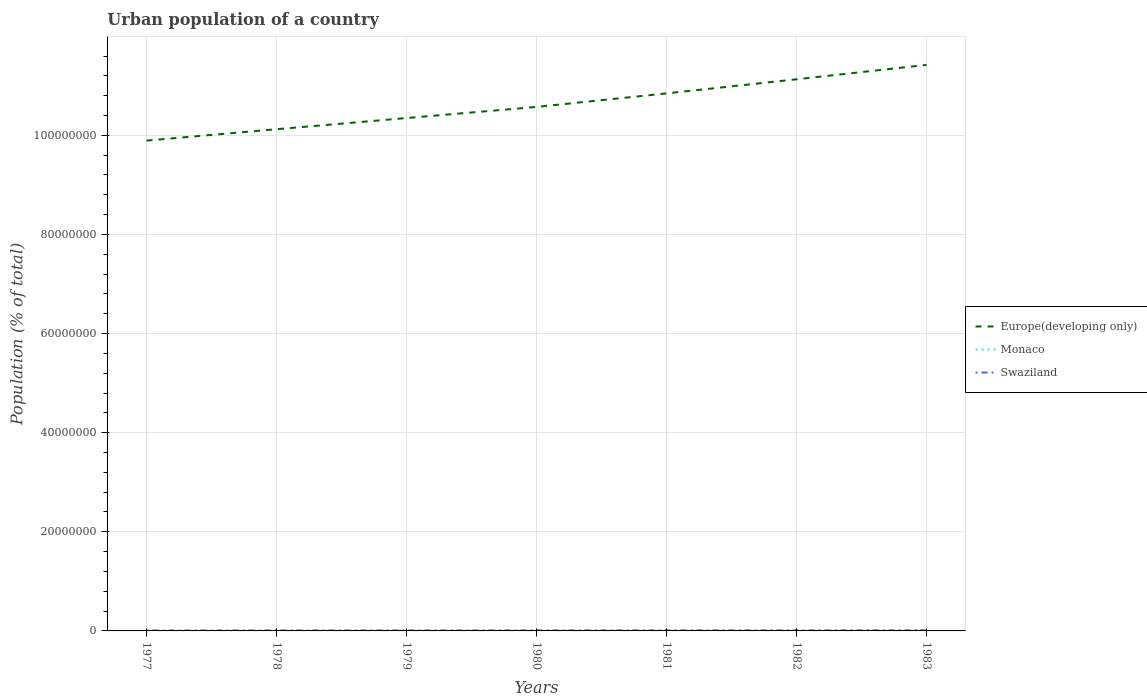How many different coloured lines are there?
Make the answer very short. 3. Does the line corresponding to Europe(developing only) intersect with the line corresponding to Swaziland?
Your answer should be compact. No. Is the number of lines equal to the number of legend labels?
Your answer should be compact. Yes. Across all years, what is the maximum urban population in Monaco?
Your response must be concise. 2.58e+04. In which year was the urban population in Europe(developing only) maximum?
Keep it short and to the point. 1977. What is the total urban population in Europe(developing only) in the graph?
Give a very brief answer. -5.76e+06. What is the difference between the highest and the second highest urban population in Europe(developing only)?
Your response must be concise. 1.53e+07. Is the urban population in Monaco strictly greater than the urban population in Swaziland over the years?
Provide a succinct answer. Yes. How many lines are there?
Offer a terse response. 3. What is the difference between two consecutive major ticks on the Y-axis?
Offer a terse response. 2.00e+07. Are the values on the major ticks of Y-axis written in scientific E-notation?
Your answer should be compact. No. How many legend labels are there?
Make the answer very short. 3. How are the legend labels stacked?
Offer a very short reply. Vertical. What is the title of the graph?
Offer a terse response. Urban population of a country. Does "Brazil" appear as one of the legend labels in the graph?
Offer a very short reply. No. What is the label or title of the X-axis?
Provide a succinct answer. Years. What is the label or title of the Y-axis?
Provide a short and direct response. Population (% of total). What is the Population (% of total) of Europe(developing only) in 1977?
Your answer should be very brief. 9.89e+07. What is the Population (% of total) of Monaco in 1977?
Ensure brevity in your answer.  2.58e+04. What is the Population (% of total) of Swaziland in 1977?
Ensure brevity in your answer.  8.67e+04. What is the Population (% of total) of Europe(developing only) in 1978?
Your answer should be compact. 1.01e+08. What is the Population (% of total) in Monaco in 1978?
Keep it short and to the point. 2.61e+04. What is the Population (% of total) of Swaziland in 1978?
Offer a very short reply. 9.32e+04. What is the Population (% of total) in Europe(developing only) in 1979?
Your answer should be compact. 1.03e+08. What is the Population (% of total) of Monaco in 1979?
Your answer should be very brief. 2.64e+04. What is the Population (% of total) of Swaziland in 1979?
Offer a terse response. 1.00e+05. What is the Population (% of total) in Europe(developing only) in 1980?
Keep it short and to the point. 1.06e+08. What is the Population (% of total) of Monaco in 1980?
Your answer should be compact. 2.67e+04. What is the Population (% of total) of Swaziland in 1980?
Offer a terse response. 1.08e+05. What is the Population (% of total) of Europe(developing only) in 1981?
Provide a succinct answer. 1.08e+08. What is the Population (% of total) of Monaco in 1981?
Keep it short and to the point. 2.72e+04. What is the Population (% of total) in Swaziland in 1981?
Make the answer very short. 1.15e+05. What is the Population (% of total) in Europe(developing only) in 1982?
Provide a short and direct response. 1.11e+08. What is the Population (% of total) in Monaco in 1982?
Ensure brevity in your answer.  2.76e+04. What is the Population (% of total) of Swaziland in 1982?
Your answer should be compact. 1.24e+05. What is the Population (% of total) in Europe(developing only) in 1983?
Give a very brief answer. 1.14e+08. What is the Population (% of total) in Monaco in 1983?
Your answer should be compact. 2.81e+04. What is the Population (% of total) of Swaziland in 1983?
Your response must be concise. 1.33e+05. Across all years, what is the maximum Population (% of total) of Europe(developing only)?
Keep it short and to the point. 1.14e+08. Across all years, what is the maximum Population (% of total) in Monaco?
Give a very brief answer. 2.81e+04. Across all years, what is the maximum Population (% of total) of Swaziland?
Make the answer very short. 1.33e+05. Across all years, what is the minimum Population (% of total) of Europe(developing only)?
Give a very brief answer. 9.89e+07. Across all years, what is the minimum Population (% of total) in Monaco?
Provide a short and direct response. 2.58e+04. Across all years, what is the minimum Population (% of total) of Swaziland?
Ensure brevity in your answer.  8.67e+04. What is the total Population (% of total) in Europe(developing only) in the graph?
Provide a succinct answer. 7.43e+08. What is the total Population (% of total) in Monaco in the graph?
Your answer should be very brief. 1.88e+05. What is the total Population (% of total) in Swaziland in the graph?
Give a very brief answer. 7.60e+05. What is the difference between the Population (% of total) in Europe(developing only) in 1977 and that in 1978?
Your answer should be very brief. -2.30e+06. What is the difference between the Population (% of total) of Monaco in 1977 and that in 1978?
Your answer should be compact. -277. What is the difference between the Population (% of total) in Swaziland in 1977 and that in 1978?
Offer a terse response. -6570. What is the difference between the Population (% of total) in Europe(developing only) in 1977 and that in 1979?
Offer a terse response. -4.55e+06. What is the difference between the Population (% of total) in Monaco in 1977 and that in 1979?
Your response must be concise. -582. What is the difference between the Population (% of total) of Swaziland in 1977 and that in 1979?
Ensure brevity in your answer.  -1.36e+04. What is the difference between the Population (% of total) in Europe(developing only) in 1977 and that in 1980?
Your response must be concise. -6.80e+06. What is the difference between the Population (% of total) in Monaco in 1977 and that in 1980?
Make the answer very short. -937. What is the difference between the Population (% of total) in Swaziland in 1977 and that in 1980?
Your answer should be very brief. -2.10e+04. What is the difference between the Population (% of total) of Europe(developing only) in 1977 and that in 1981?
Your response must be concise. -9.52e+06. What is the difference between the Population (% of total) in Monaco in 1977 and that in 1981?
Your answer should be compact. -1356. What is the difference between the Population (% of total) of Swaziland in 1977 and that in 1981?
Your response must be concise. -2.88e+04. What is the difference between the Population (% of total) in Europe(developing only) in 1977 and that in 1982?
Ensure brevity in your answer.  -1.24e+07. What is the difference between the Population (% of total) of Monaco in 1977 and that in 1982?
Keep it short and to the point. -1820. What is the difference between the Population (% of total) in Swaziland in 1977 and that in 1982?
Make the answer very short. -3.71e+04. What is the difference between the Population (% of total) in Europe(developing only) in 1977 and that in 1983?
Provide a succinct answer. -1.53e+07. What is the difference between the Population (% of total) of Monaco in 1977 and that in 1983?
Give a very brief answer. -2289. What is the difference between the Population (% of total) in Swaziland in 1977 and that in 1983?
Give a very brief answer. -4.60e+04. What is the difference between the Population (% of total) of Europe(developing only) in 1978 and that in 1979?
Give a very brief answer. -2.25e+06. What is the difference between the Population (% of total) in Monaco in 1978 and that in 1979?
Keep it short and to the point. -305. What is the difference between the Population (% of total) of Swaziland in 1978 and that in 1979?
Keep it short and to the point. -7000. What is the difference between the Population (% of total) in Europe(developing only) in 1978 and that in 1980?
Your answer should be compact. -4.50e+06. What is the difference between the Population (% of total) in Monaco in 1978 and that in 1980?
Your answer should be very brief. -660. What is the difference between the Population (% of total) of Swaziland in 1978 and that in 1980?
Give a very brief answer. -1.44e+04. What is the difference between the Population (% of total) of Europe(developing only) in 1978 and that in 1981?
Your response must be concise. -7.22e+06. What is the difference between the Population (% of total) of Monaco in 1978 and that in 1981?
Give a very brief answer. -1079. What is the difference between the Population (% of total) of Swaziland in 1978 and that in 1981?
Keep it short and to the point. -2.23e+04. What is the difference between the Population (% of total) of Europe(developing only) in 1978 and that in 1982?
Your response must be concise. -1.01e+07. What is the difference between the Population (% of total) of Monaco in 1978 and that in 1982?
Your response must be concise. -1543. What is the difference between the Population (% of total) in Swaziland in 1978 and that in 1982?
Keep it short and to the point. -3.05e+04. What is the difference between the Population (% of total) in Europe(developing only) in 1978 and that in 1983?
Ensure brevity in your answer.  -1.30e+07. What is the difference between the Population (% of total) of Monaco in 1978 and that in 1983?
Offer a terse response. -2012. What is the difference between the Population (% of total) in Swaziland in 1978 and that in 1983?
Provide a succinct answer. -3.94e+04. What is the difference between the Population (% of total) in Europe(developing only) in 1979 and that in 1980?
Provide a succinct answer. -2.25e+06. What is the difference between the Population (% of total) in Monaco in 1979 and that in 1980?
Provide a short and direct response. -355. What is the difference between the Population (% of total) in Swaziland in 1979 and that in 1980?
Your answer should be very brief. -7445. What is the difference between the Population (% of total) of Europe(developing only) in 1979 and that in 1981?
Provide a succinct answer. -4.97e+06. What is the difference between the Population (% of total) in Monaco in 1979 and that in 1981?
Ensure brevity in your answer.  -774. What is the difference between the Population (% of total) of Swaziland in 1979 and that in 1981?
Ensure brevity in your answer.  -1.53e+04. What is the difference between the Population (% of total) in Europe(developing only) in 1979 and that in 1982?
Your response must be concise. -7.82e+06. What is the difference between the Population (% of total) of Monaco in 1979 and that in 1982?
Provide a short and direct response. -1238. What is the difference between the Population (% of total) in Swaziland in 1979 and that in 1982?
Ensure brevity in your answer.  -2.35e+04. What is the difference between the Population (% of total) of Europe(developing only) in 1979 and that in 1983?
Provide a succinct answer. -1.07e+07. What is the difference between the Population (% of total) in Monaco in 1979 and that in 1983?
Make the answer very short. -1707. What is the difference between the Population (% of total) of Swaziland in 1979 and that in 1983?
Your response must be concise. -3.24e+04. What is the difference between the Population (% of total) of Europe(developing only) in 1980 and that in 1981?
Give a very brief answer. -2.73e+06. What is the difference between the Population (% of total) in Monaco in 1980 and that in 1981?
Provide a succinct answer. -419. What is the difference between the Population (% of total) in Swaziland in 1980 and that in 1981?
Keep it short and to the point. -7818. What is the difference between the Population (% of total) in Europe(developing only) in 1980 and that in 1982?
Make the answer very short. -5.58e+06. What is the difference between the Population (% of total) in Monaco in 1980 and that in 1982?
Your response must be concise. -883. What is the difference between the Population (% of total) of Swaziland in 1980 and that in 1982?
Offer a very short reply. -1.61e+04. What is the difference between the Population (% of total) in Europe(developing only) in 1980 and that in 1983?
Offer a very short reply. -8.48e+06. What is the difference between the Population (% of total) in Monaco in 1980 and that in 1983?
Provide a short and direct response. -1352. What is the difference between the Population (% of total) of Swaziland in 1980 and that in 1983?
Your answer should be compact. -2.50e+04. What is the difference between the Population (% of total) in Europe(developing only) in 1981 and that in 1982?
Keep it short and to the point. -2.85e+06. What is the difference between the Population (% of total) in Monaco in 1981 and that in 1982?
Provide a succinct answer. -464. What is the difference between the Population (% of total) in Swaziland in 1981 and that in 1982?
Provide a short and direct response. -8260. What is the difference between the Population (% of total) of Europe(developing only) in 1981 and that in 1983?
Offer a terse response. -5.76e+06. What is the difference between the Population (% of total) in Monaco in 1981 and that in 1983?
Make the answer very short. -933. What is the difference between the Population (% of total) in Swaziland in 1981 and that in 1983?
Offer a terse response. -1.72e+04. What is the difference between the Population (% of total) in Europe(developing only) in 1982 and that in 1983?
Provide a short and direct response. -2.91e+06. What is the difference between the Population (% of total) of Monaco in 1982 and that in 1983?
Offer a very short reply. -469. What is the difference between the Population (% of total) in Swaziland in 1982 and that in 1983?
Offer a very short reply. -8924. What is the difference between the Population (% of total) in Europe(developing only) in 1977 and the Population (% of total) in Monaco in 1978?
Your response must be concise. 9.89e+07. What is the difference between the Population (% of total) of Europe(developing only) in 1977 and the Population (% of total) of Swaziland in 1978?
Give a very brief answer. 9.88e+07. What is the difference between the Population (% of total) of Monaco in 1977 and the Population (% of total) of Swaziland in 1978?
Keep it short and to the point. -6.74e+04. What is the difference between the Population (% of total) in Europe(developing only) in 1977 and the Population (% of total) in Monaco in 1979?
Your response must be concise. 9.89e+07. What is the difference between the Population (% of total) in Europe(developing only) in 1977 and the Population (% of total) in Swaziland in 1979?
Your answer should be very brief. 9.88e+07. What is the difference between the Population (% of total) in Monaco in 1977 and the Population (% of total) in Swaziland in 1979?
Your answer should be compact. -7.44e+04. What is the difference between the Population (% of total) of Europe(developing only) in 1977 and the Population (% of total) of Monaco in 1980?
Make the answer very short. 9.89e+07. What is the difference between the Population (% of total) in Europe(developing only) in 1977 and the Population (% of total) in Swaziland in 1980?
Keep it short and to the point. 9.88e+07. What is the difference between the Population (% of total) of Monaco in 1977 and the Population (% of total) of Swaziland in 1980?
Provide a succinct answer. -8.19e+04. What is the difference between the Population (% of total) of Europe(developing only) in 1977 and the Population (% of total) of Monaco in 1981?
Your response must be concise. 9.89e+07. What is the difference between the Population (% of total) of Europe(developing only) in 1977 and the Population (% of total) of Swaziland in 1981?
Give a very brief answer. 9.88e+07. What is the difference between the Population (% of total) in Monaco in 1977 and the Population (% of total) in Swaziland in 1981?
Keep it short and to the point. -8.97e+04. What is the difference between the Population (% of total) in Europe(developing only) in 1977 and the Population (% of total) in Monaco in 1982?
Ensure brevity in your answer.  9.89e+07. What is the difference between the Population (% of total) of Europe(developing only) in 1977 and the Population (% of total) of Swaziland in 1982?
Offer a very short reply. 9.88e+07. What is the difference between the Population (% of total) of Monaco in 1977 and the Population (% of total) of Swaziland in 1982?
Your response must be concise. -9.79e+04. What is the difference between the Population (% of total) of Europe(developing only) in 1977 and the Population (% of total) of Monaco in 1983?
Offer a terse response. 9.89e+07. What is the difference between the Population (% of total) in Europe(developing only) in 1977 and the Population (% of total) in Swaziland in 1983?
Keep it short and to the point. 9.88e+07. What is the difference between the Population (% of total) of Monaco in 1977 and the Population (% of total) of Swaziland in 1983?
Offer a terse response. -1.07e+05. What is the difference between the Population (% of total) in Europe(developing only) in 1978 and the Population (% of total) in Monaco in 1979?
Provide a short and direct response. 1.01e+08. What is the difference between the Population (% of total) in Europe(developing only) in 1978 and the Population (% of total) in Swaziland in 1979?
Your answer should be compact. 1.01e+08. What is the difference between the Population (% of total) of Monaco in 1978 and the Population (% of total) of Swaziland in 1979?
Make the answer very short. -7.41e+04. What is the difference between the Population (% of total) in Europe(developing only) in 1978 and the Population (% of total) in Monaco in 1980?
Your answer should be very brief. 1.01e+08. What is the difference between the Population (% of total) of Europe(developing only) in 1978 and the Population (% of total) of Swaziland in 1980?
Provide a succinct answer. 1.01e+08. What is the difference between the Population (% of total) of Monaco in 1978 and the Population (% of total) of Swaziland in 1980?
Keep it short and to the point. -8.16e+04. What is the difference between the Population (% of total) in Europe(developing only) in 1978 and the Population (% of total) in Monaco in 1981?
Keep it short and to the point. 1.01e+08. What is the difference between the Population (% of total) in Europe(developing only) in 1978 and the Population (% of total) in Swaziland in 1981?
Provide a succinct answer. 1.01e+08. What is the difference between the Population (% of total) of Monaco in 1978 and the Population (% of total) of Swaziland in 1981?
Your answer should be very brief. -8.94e+04. What is the difference between the Population (% of total) of Europe(developing only) in 1978 and the Population (% of total) of Monaco in 1982?
Ensure brevity in your answer.  1.01e+08. What is the difference between the Population (% of total) in Europe(developing only) in 1978 and the Population (% of total) in Swaziland in 1982?
Your response must be concise. 1.01e+08. What is the difference between the Population (% of total) in Monaco in 1978 and the Population (% of total) in Swaziland in 1982?
Offer a very short reply. -9.77e+04. What is the difference between the Population (% of total) in Europe(developing only) in 1978 and the Population (% of total) in Monaco in 1983?
Make the answer very short. 1.01e+08. What is the difference between the Population (% of total) in Europe(developing only) in 1978 and the Population (% of total) in Swaziland in 1983?
Offer a very short reply. 1.01e+08. What is the difference between the Population (% of total) of Monaco in 1978 and the Population (% of total) of Swaziland in 1983?
Offer a very short reply. -1.07e+05. What is the difference between the Population (% of total) in Europe(developing only) in 1979 and the Population (% of total) in Monaco in 1980?
Your response must be concise. 1.03e+08. What is the difference between the Population (% of total) in Europe(developing only) in 1979 and the Population (% of total) in Swaziland in 1980?
Make the answer very short. 1.03e+08. What is the difference between the Population (% of total) in Monaco in 1979 and the Population (% of total) in Swaziland in 1980?
Provide a short and direct response. -8.13e+04. What is the difference between the Population (% of total) in Europe(developing only) in 1979 and the Population (% of total) in Monaco in 1981?
Provide a succinct answer. 1.03e+08. What is the difference between the Population (% of total) of Europe(developing only) in 1979 and the Population (% of total) of Swaziland in 1981?
Your answer should be very brief. 1.03e+08. What is the difference between the Population (% of total) of Monaco in 1979 and the Population (% of total) of Swaziland in 1981?
Your answer should be compact. -8.91e+04. What is the difference between the Population (% of total) of Europe(developing only) in 1979 and the Population (% of total) of Monaco in 1982?
Provide a succinct answer. 1.03e+08. What is the difference between the Population (% of total) in Europe(developing only) in 1979 and the Population (% of total) in Swaziland in 1982?
Your response must be concise. 1.03e+08. What is the difference between the Population (% of total) in Monaco in 1979 and the Population (% of total) in Swaziland in 1982?
Offer a terse response. -9.74e+04. What is the difference between the Population (% of total) in Europe(developing only) in 1979 and the Population (% of total) in Monaco in 1983?
Your answer should be very brief. 1.03e+08. What is the difference between the Population (% of total) of Europe(developing only) in 1979 and the Population (% of total) of Swaziland in 1983?
Your response must be concise. 1.03e+08. What is the difference between the Population (% of total) in Monaco in 1979 and the Population (% of total) in Swaziland in 1983?
Make the answer very short. -1.06e+05. What is the difference between the Population (% of total) in Europe(developing only) in 1980 and the Population (% of total) in Monaco in 1981?
Offer a terse response. 1.06e+08. What is the difference between the Population (% of total) in Europe(developing only) in 1980 and the Population (% of total) in Swaziland in 1981?
Offer a terse response. 1.06e+08. What is the difference between the Population (% of total) of Monaco in 1980 and the Population (% of total) of Swaziland in 1981?
Your answer should be very brief. -8.88e+04. What is the difference between the Population (% of total) of Europe(developing only) in 1980 and the Population (% of total) of Monaco in 1982?
Offer a very short reply. 1.06e+08. What is the difference between the Population (% of total) of Europe(developing only) in 1980 and the Population (% of total) of Swaziland in 1982?
Ensure brevity in your answer.  1.06e+08. What is the difference between the Population (% of total) of Monaco in 1980 and the Population (% of total) of Swaziland in 1982?
Your response must be concise. -9.70e+04. What is the difference between the Population (% of total) in Europe(developing only) in 1980 and the Population (% of total) in Monaco in 1983?
Keep it short and to the point. 1.06e+08. What is the difference between the Population (% of total) in Europe(developing only) in 1980 and the Population (% of total) in Swaziland in 1983?
Make the answer very short. 1.06e+08. What is the difference between the Population (% of total) in Monaco in 1980 and the Population (% of total) in Swaziland in 1983?
Offer a very short reply. -1.06e+05. What is the difference between the Population (% of total) of Europe(developing only) in 1981 and the Population (% of total) of Monaco in 1982?
Keep it short and to the point. 1.08e+08. What is the difference between the Population (% of total) of Europe(developing only) in 1981 and the Population (% of total) of Swaziland in 1982?
Make the answer very short. 1.08e+08. What is the difference between the Population (% of total) of Monaco in 1981 and the Population (% of total) of Swaziland in 1982?
Your response must be concise. -9.66e+04. What is the difference between the Population (% of total) of Europe(developing only) in 1981 and the Population (% of total) of Monaco in 1983?
Make the answer very short. 1.08e+08. What is the difference between the Population (% of total) of Europe(developing only) in 1981 and the Population (% of total) of Swaziland in 1983?
Ensure brevity in your answer.  1.08e+08. What is the difference between the Population (% of total) in Monaco in 1981 and the Population (% of total) in Swaziland in 1983?
Provide a succinct answer. -1.06e+05. What is the difference between the Population (% of total) in Europe(developing only) in 1982 and the Population (% of total) in Monaco in 1983?
Your answer should be very brief. 1.11e+08. What is the difference between the Population (% of total) of Europe(developing only) in 1982 and the Population (% of total) of Swaziland in 1983?
Give a very brief answer. 1.11e+08. What is the difference between the Population (% of total) in Monaco in 1982 and the Population (% of total) in Swaziland in 1983?
Provide a succinct answer. -1.05e+05. What is the average Population (% of total) of Europe(developing only) per year?
Offer a terse response. 1.06e+08. What is the average Population (% of total) in Monaco per year?
Provide a succinct answer. 2.68e+04. What is the average Population (% of total) of Swaziland per year?
Your response must be concise. 1.09e+05. In the year 1977, what is the difference between the Population (% of total) of Europe(developing only) and Population (% of total) of Monaco?
Your answer should be compact. 9.89e+07. In the year 1977, what is the difference between the Population (% of total) of Europe(developing only) and Population (% of total) of Swaziland?
Ensure brevity in your answer.  9.88e+07. In the year 1977, what is the difference between the Population (% of total) of Monaco and Population (% of total) of Swaziland?
Your answer should be compact. -6.09e+04. In the year 1978, what is the difference between the Population (% of total) of Europe(developing only) and Population (% of total) of Monaco?
Your response must be concise. 1.01e+08. In the year 1978, what is the difference between the Population (% of total) in Europe(developing only) and Population (% of total) in Swaziland?
Give a very brief answer. 1.01e+08. In the year 1978, what is the difference between the Population (% of total) of Monaco and Population (% of total) of Swaziland?
Keep it short and to the point. -6.71e+04. In the year 1979, what is the difference between the Population (% of total) in Europe(developing only) and Population (% of total) in Monaco?
Provide a succinct answer. 1.03e+08. In the year 1979, what is the difference between the Population (% of total) of Europe(developing only) and Population (% of total) of Swaziland?
Provide a succinct answer. 1.03e+08. In the year 1979, what is the difference between the Population (% of total) in Monaco and Population (% of total) in Swaziland?
Your answer should be very brief. -7.38e+04. In the year 1980, what is the difference between the Population (% of total) in Europe(developing only) and Population (% of total) in Monaco?
Your response must be concise. 1.06e+08. In the year 1980, what is the difference between the Population (% of total) in Europe(developing only) and Population (% of total) in Swaziland?
Keep it short and to the point. 1.06e+08. In the year 1980, what is the difference between the Population (% of total) of Monaco and Population (% of total) of Swaziland?
Your answer should be very brief. -8.09e+04. In the year 1981, what is the difference between the Population (% of total) in Europe(developing only) and Population (% of total) in Monaco?
Provide a succinct answer. 1.08e+08. In the year 1981, what is the difference between the Population (% of total) of Europe(developing only) and Population (% of total) of Swaziland?
Give a very brief answer. 1.08e+08. In the year 1981, what is the difference between the Population (% of total) in Monaco and Population (% of total) in Swaziland?
Keep it short and to the point. -8.83e+04. In the year 1982, what is the difference between the Population (% of total) of Europe(developing only) and Population (% of total) of Monaco?
Give a very brief answer. 1.11e+08. In the year 1982, what is the difference between the Population (% of total) of Europe(developing only) and Population (% of total) of Swaziland?
Give a very brief answer. 1.11e+08. In the year 1982, what is the difference between the Population (% of total) in Monaco and Population (% of total) in Swaziland?
Give a very brief answer. -9.61e+04. In the year 1983, what is the difference between the Population (% of total) of Europe(developing only) and Population (% of total) of Monaco?
Your answer should be very brief. 1.14e+08. In the year 1983, what is the difference between the Population (% of total) in Europe(developing only) and Population (% of total) in Swaziland?
Offer a terse response. 1.14e+08. In the year 1983, what is the difference between the Population (% of total) in Monaco and Population (% of total) in Swaziland?
Your response must be concise. -1.05e+05. What is the ratio of the Population (% of total) of Europe(developing only) in 1977 to that in 1978?
Give a very brief answer. 0.98. What is the ratio of the Population (% of total) in Swaziland in 1977 to that in 1978?
Provide a succinct answer. 0.93. What is the ratio of the Population (% of total) of Europe(developing only) in 1977 to that in 1979?
Provide a short and direct response. 0.96. What is the ratio of the Population (% of total) in Monaco in 1977 to that in 1979?
Make the answer very short. 0.98. What is the ratio of the Population (% of total) of Swaziland in 1977 to that in 1979?
Your answer should be compact. 0.86. What is the ratio of the Population (% of total) in Europe(developing only) in 1977 to that in 1980?
Give a very brief answer. 0.94. What is the ratio of the Population (% of total) of Swaziland in 1977 to that in 1980?
Ensure brevity in your answer.  0.8. What is the ratio of the Population (% of total) in Europe(developing only) in 1977 to that in 1981?
Provide a short and direct response. 0.91. What is the ratio of the Population (% of total) in Monaco in 1977 to that in 1981?
Offer a terse response. 0.95. What is the ratio of the Population (% of total) in Swaziland in 1977 to that in 1981?
Your response must be concise. 0.75. What is the ratio of the Population (% of total) in Europe(developing only) in 1977 to that in 1982?
Your answer should be very brief. 0.89. What is the ratio of the Population (% of total) in Monaco in 1977 to that in 1982?
Provide a short and direct response. 0.93. What is the ratio of the Population (% of total) of Swaziland in 1977 to that in 1982?
Provide a short and direct response. 0.7. What is the ratio of the Population (% of total) in Europe(developing only) in 1977 to that in 1983?
Ensure brevity in your answer.  0.87. What is the ratio of the Population (% of total) of Monaco in 1977 to that in 1983?
Offer a terse response. 0.92. What is the ratio of the Population (% of total) of Swaziland in 1977 to that in 1983?
Make the answer very short. 0.65. What is the ratio of the Population (% of total) in Europe(developing only) in 1978 to that in 1979?
Provide a succinct answer. 0.98. What is the ratio of the Population (% of total) in Monaco in 1978 to that in 1979?
Offer a very short reply. 0.99. What is the ratio of the Population (% of total) in Swaziland in 1978 to that in 1979?
Keep it short and to the point. 0.93. What is the ratio of the Population (% of total) in Europe(developing only) in 1978 to that in 1980?
Make the answer very short. 0.96. What is the ratio of the Population (% of total) in Monaco in 1978 to that in 1980?
Provide a succinct answer. 0.98. What is the ratio of the Population (% of total) in Swaziland in 1978 to that in 1980?
Provide a short and direct response. 0.87. What is the ratio of the Population (% of total) of Europe(developing only) in 1978 to that in 1981?
Keep it short and to the point. 0.93. What is the ratio of the Population (% of total) in Monaco in 1978 to that in 1981?
Your answer should be compact. 0.96. What is the ratio of the Population (% of total) in Swaziland in 1978 to that in 1981?
Provide a succinct answer. 0.81. What is the ratio of the Population (% of total) in Europe(developing only) in 1978 to that in 1982?
Keep it short and to the point. 0.91. What is the ratio of the Population (% of total) in Monaco in 1978 to that in 1982?
Your answer should be compact. 0.94. What is the ratio of the Population (% of total) in Swaziland in 1978 to that in 1982?
Ensure brevity in your answer.  0.75. What is the ratio of the Population (% of total) in Europe(developing only) in 1978 to that in 1983?
Provide a short and direct response. 0.89. What is the ratio of the Population (% of total) of Monaco in 1978 to that in 1983?
Make the answer very short. 0.93. What is the ratio of the Population (% of total) in Swaziland in 1978 to that in 1983?
Your answer should be compact. 0.7. What is the ratio of the Population (% of total) of Europe(developing only) in 1979 to that in 1980?
Give a very brief answer. 0.98. What is the ratio of the Population (% of total) in Monaco in 1979 to that in 1980?
Offer a terse response. 0.99. What is the ratio of the Population (% of total) of Swaziland in 1979 to that in 1980?
Your response must be concise. 0.93. What is the ratio of the Population (% of total) of Europe(developing only) in 1979 to that in 1981?
Your answer should be compact. 0.95. What is the ratio of the Population (% of total) of Monaco in 1979 to that in 1981?
Give a very brief answer. 0.97. What is the ratio of the Population (% of total) in Swaziland in 1979 to that in 1981?
Provide a succinct answer. 0.87. What is the ratio of the Population (% of total) of Europe(developing only) in 1979 to that in 1982?
Your response must be concise. 0.93. What is the ratio of the Population (% of total) of Monaco in 1979 to that in 1982?
Your answer should be compact. 0.96. What is the ratio of the Population (% of total) of Swaziland in 1979 to that in 1982?
Your response must be concise. 0.81. What is the ratio of the Population (% of total) in Europe(developing only) in 1979 to that in 1983?
Provide a succinct answer. 0.91. What is the ratio of the Population (% of total) in Monaco in 1979 to that in 1983?
Your answer should be very brief. 0.94. What is the ratio of the Population (% of total) in Swaziland in 1979 to that in 1983?
Offer a terse response. 0.76. What is the ratio of the Population (% of total) in Europe(developing only) in 1980 to that in 1981?
Offer a terse response. 0.97. What is the ratio of the Population (% of total) of Monaco in 1980 to that in 1981?
Offer a terse response. 0.98. What is the ratio of the Population (% of total) in Swaziland in 1980 to that in 1981?
Offer a terse response. 0.93. What is the ratio of the Population (% of total) of Europe(developing only) in 1980 to that in 1982?
Keep it short and to the point. 0.95. What is the ratio of the Population (% of total) of Monaco in 1980 to that in 1982?
Your answer should be compact. 0.97. What is the ratio of the Population (% of total) in Swaziland in 1980 to that in 1982?
Make the answer very short. 0.87. What is the ratio of the Population (% of total) in Europe(developing only) in 1980 to that in 1983?
Provide a short and direct response. 0.93. What is the ratio of the Population (% of total) in Monaco in 1980 to that in 1983?
Offer a terse response. 0.95. What is the ratio of the Population (% of total) in Swaziland in 1980 to that in 1983?
Offer a very short reply. 0.81. What is the ratio of the Population (% of total) of Europe(developing only) in 1981 to that in 1982?
Your response must be concise. 0.97. What is the ratio of the Population (% of total) of Monaco in 1981 to that in 1982?
Make the answer very short. 0.98. What is the ratio of the Population (% of total) of Swaziland in 1981 to that in 1982?
Ensure brevity in your answer.  0.93. What is the ratio of the Population (% of total) of Europe(developing only) in 1981 to that in 1983?
Keep it short and to the point. 0.95. What is the ratio of the Population (% of total) of Monaco in 1981 to that in 1983?
Give a very brief answer. 0.97. What is the ratio of the Population (% of total) of Swaziland in 1981 to that in 1983?
Keep it short and to the point. 0.87. What is the ratio of the Population (% of total) in Europe(developing only) in 1982 to that in 1983?
Your response must be concise. 0.97. What is the ratio of the Population (% of total) in Monaco in 1982 to that in 1983?
Offer a terse response. 0.98. What is the ratio of the Population (% of total) in Swaziland in 1982 to that in 1983?
Offer a very short reply. 0.93. What is the difference between the highest and the second highest Population (% of total) of Europe(developing only)?
Your response must be concise. 2.91e+06. What is the difference between the highest and the second highest Population (% of total) of Monaco?
Provide a succinct answer. 469. What is the difference between the highest and the second highest Population (% of total) in Swaziland?
Give a very brief answer. 8924. What is the difference between the highest and the lowest Population (% of total) in Europe(developing only)?
Your answer should be compact. 1.53e+07. What is the difference between the highest and the lowest Population (% of total) of Monaco?
Provide a succinct answer. 2289. What is the difference between the highest and the lowest Population (% of total) in Swaziland?
Give a very brief answer. 4.60e+04. 